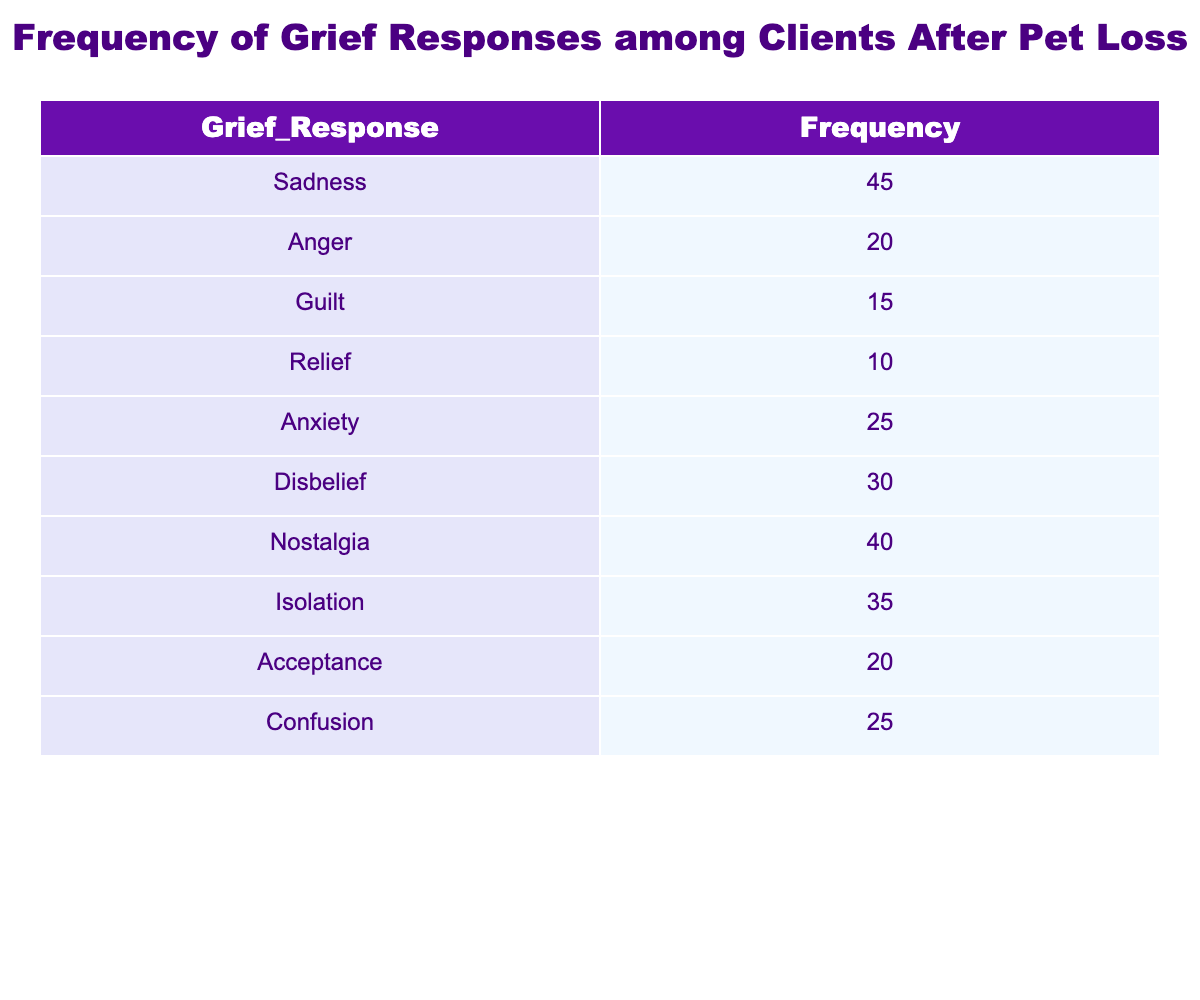What is the frequency of feelings of sadness among clients after pet loss? The table lists "Sadness" with a frequency value of 45. Therefore, the frequency of feelings of sadness is directly given in the table.
Answer: 45 How many clients experienced anxiety as a grief response? The table indicates that "Anxiety" has a frequency of 25. This value can be retrieved directly from the table, confirming the number of clients experiencing this response.
Answer: 25 What is the total frequency of clients experiencing guilt, relief, and acceptance combined? To find the total, add the frequencies for Guilt (15), Relief (10), and Acceptance (20): 15 + 10 + 20 = 45. This gives the combined total of clients experiencing these feelings.
Answer: 45 Is it true that more clients felt nostalgia than guilt after pet loss? The frequency for Nostalgia is 40, and for Guilt, it is 15. Since 40 is greater than 15, it confirms that more clients felt nostalgia than guilt.
Answer: Yes What is the difference in frequency between feelings of disbelief and isolation? The frequency for Disbelief is 30, and for Isolation, it is 35. To find the difference, subtract the smaller from the larger: 35 - 30 = 5. This shows how many more clients felt isolation compared to disbelief.
Answer: 5 What percentage of clients reported feelings of relief among all reported grief responses? First, calculate the total frequency: 45 + 20 + 15 + 10 + 25 + 30 + 40 + 35 + 20 + 25 =  315. Then, divide the frequency of Relief (10) by the total (315) and multiply by 100 to get the percentage: (10/315) * 100 ≈ 3.17%. This calculation shows the portion of clients experiencing relief.
Answer: Approximately 3.17% What is the most common grief response among clients after pet loss? By examining the frequencies, Sadness has the highest frequency of 45, making it the most common grief response.
Answer: Sadness How many clients showed confusion as a grief response? The table lists "Confusion" with a frequency of 25. This answer can be identified directly from the table.
Answer: 25 What is the average frequency of all grief responses listed in the table? First, sum up all the frequencies: 45 + 20 + 15 + 10 + 25 + 30 + 40 + 35 + 20 + 25 = 315. There are 10 responses, so average is: 315 / 10 = 31.5. This gives an idea of the general level of grief responses reported by clients.
Answer: 31.5 